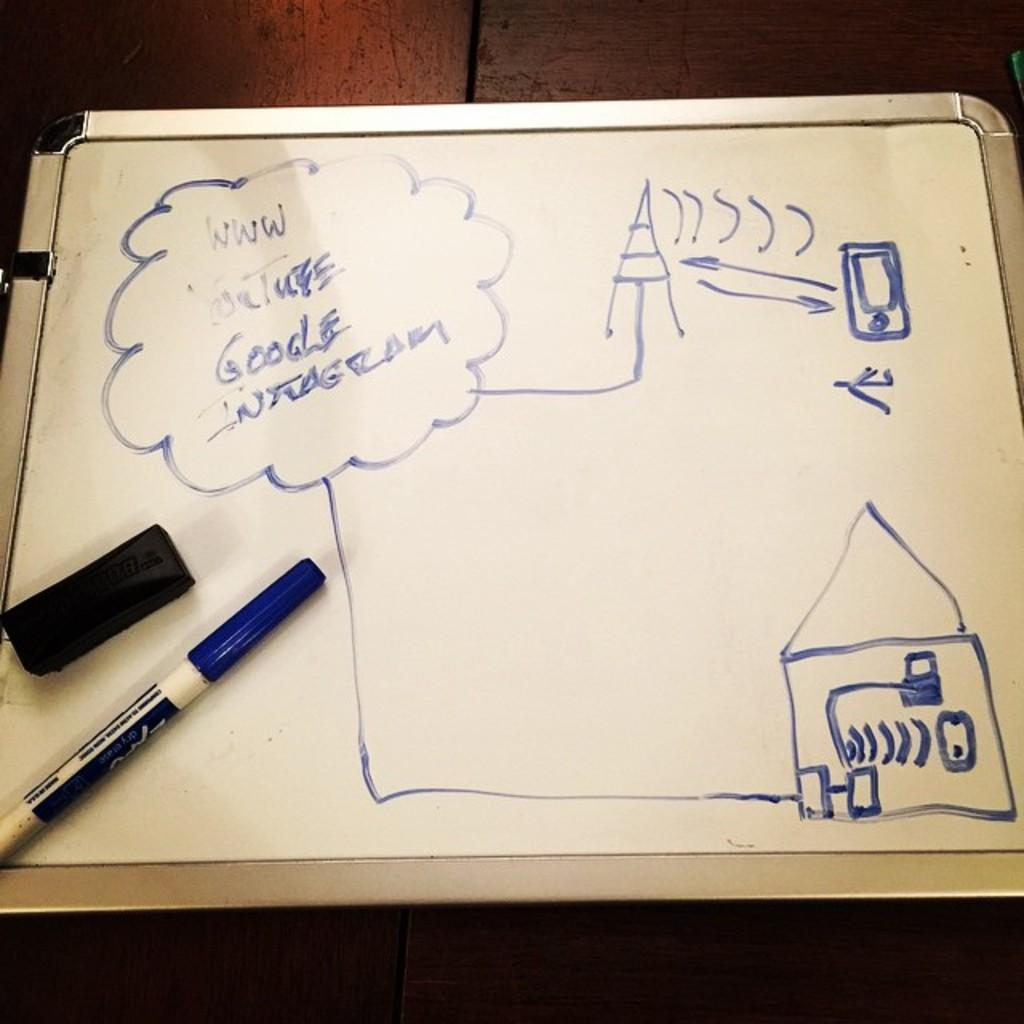Provide a one-sentence caption for the provided image. A white board with a drawing on it and the words YouTube, Google and Instagram in the corner. 